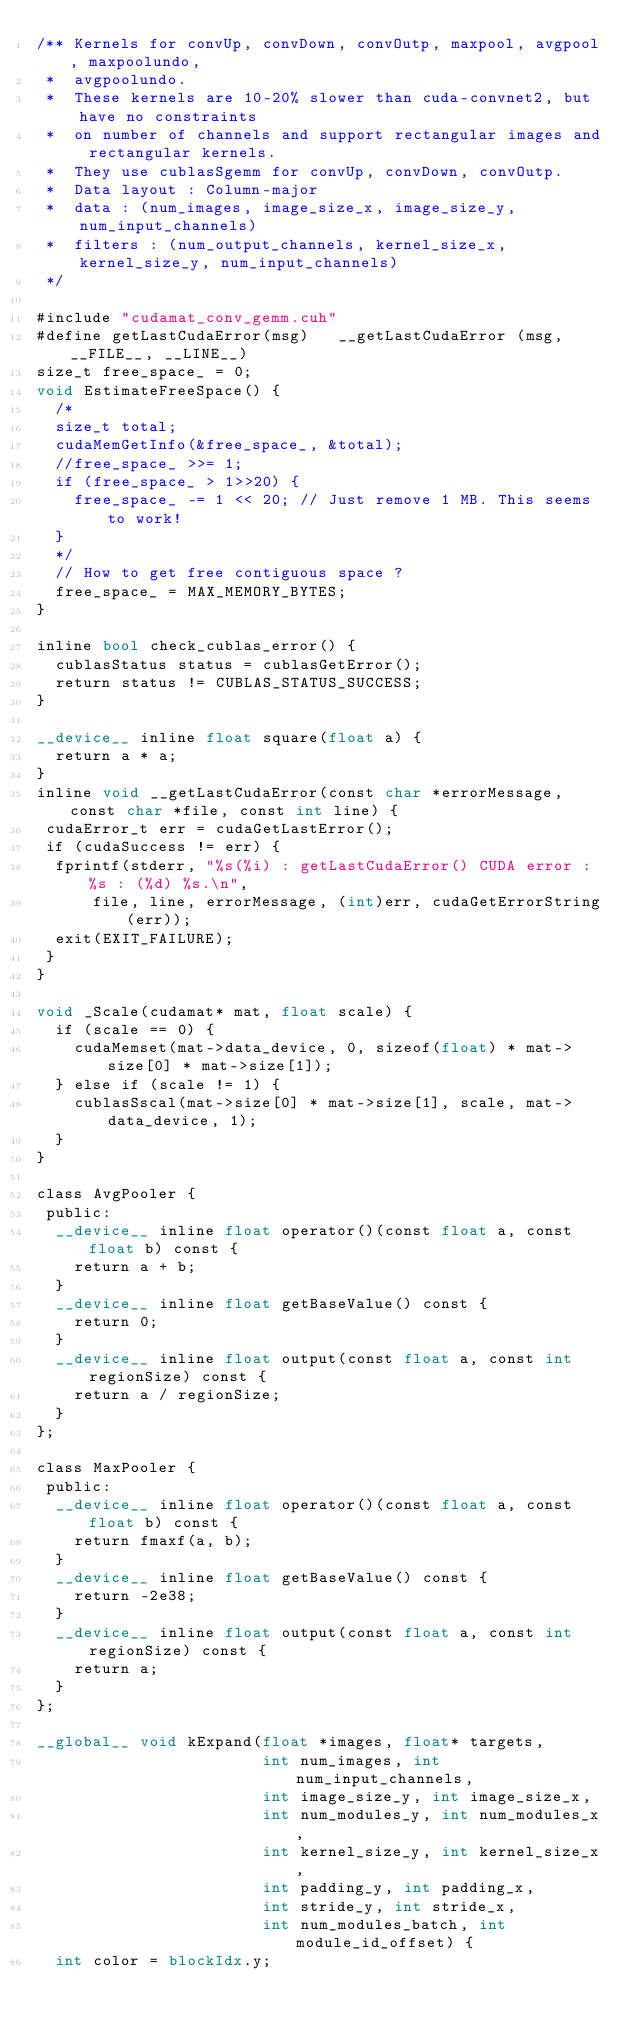<code> <loc_0><loc_0><loc_500><loc_500><_Cuda_>/** Kernels for convUp, convDown, convOutp, maxpool, avgpool, maxpoolundo,
 *  avgpoolundo.
 *  These kernels are 10-20% slower than cuda-convnet2, but have no constraints
 *  on number of channels and support rectangular images and rectangular kernels.
 *  They use cublasSgemm for convUp, convDown, convOutp.
 *  Data layout : Column-major
 *  data : (num_images, image_size_x, image_size_y, num_input_channels)
 *  filters : (num_output_channels, kernel_size_x, kernel_size_y, num_input_channels)
 */

#include "cudamat_conv_gemm.cuh"
#define getLastCudaError(msg)   __getLastCudaError (msg, __FILE__, __LINE__)
size_t free_space_ = 0;
void EstimateFreeSpace() {
  /*
  size_t total;
  cudaMemGetInfo(&free_space_, &total);
  //free_space_ >>= 1;
  if (free_space_ > 1>>20) {
    free_space_ -= 1 << 20; // Just remove 1 MB. This seems to work!
  }
  */
  // How to get free contiguous space ?
  free_space_ = MAX_MEMORY_BYTES;
}

inline bool check_cublas_error() {
  cublasStatus status = cublasGetError();
  return status != CUBLAS_STATUS_SUCCESS;
}

__device__ inline float square(float a) {
  return a * a;
}
inline void __getLastCudaError(const char *errorMessage, const char *file, const int line) {
 cudaError_t err = cudaGetLastError();
 if (cudaSuccess != err) {
  fprintf(stderr, "%s(%i) : getLastCudaError() CUDA error : %s : (%d) %s.\n",
      file, line, errorMessage, (int)err, cudaGetErrorString(err));
  exit(EXIT_FAILURE);
 }
}

void _Scale(cudamat* mat, float scale) {
  if (scale == 0) {
    cudaMemset(mat->data_device, 0, sizeof(float) * mat->size[0] * mat->size[1]);
  } else if (scale != 1) {
    cublasSscal(mat->size[0] * mat->size[1], scale, mat->data_device, 1);
  }
}

class AvgPooler {
 public:
  __device__ inline float operator()(const float a, const float b) const {
    return a + b;
  }
  __device__ inline float getBaseValue() const {
    return 0;
  }
  __device__ inline float output(const float a, const int regionSize) const {
    return a / regionSize;
  }
};

class MaxPooler {
 public:
  __device__ inline float operator()(const float a, const float b) const {
    return fmaxf(a, b);
  }
  __device__ inline float getBaseValue() const {
    return -2e38; 
  }
  __device__ inline float output(const float a, const int regionSize) const {
    return a;
  }
};

__global__ void kExpand(float *images, float* targets,
                        int num_images, int num_input_channels,
                        int image_size_y, int image_size_x,
                        int num_modules_y, int num_modules_x,
                        int kernel_size_y, int kernel_size_x,
                        int padding_y, int padding_x,
                        int stride_y, int stride_x,
                        int num_modules_batch, int module_id_offset) {
  int color = blockIdx.y;</code> 